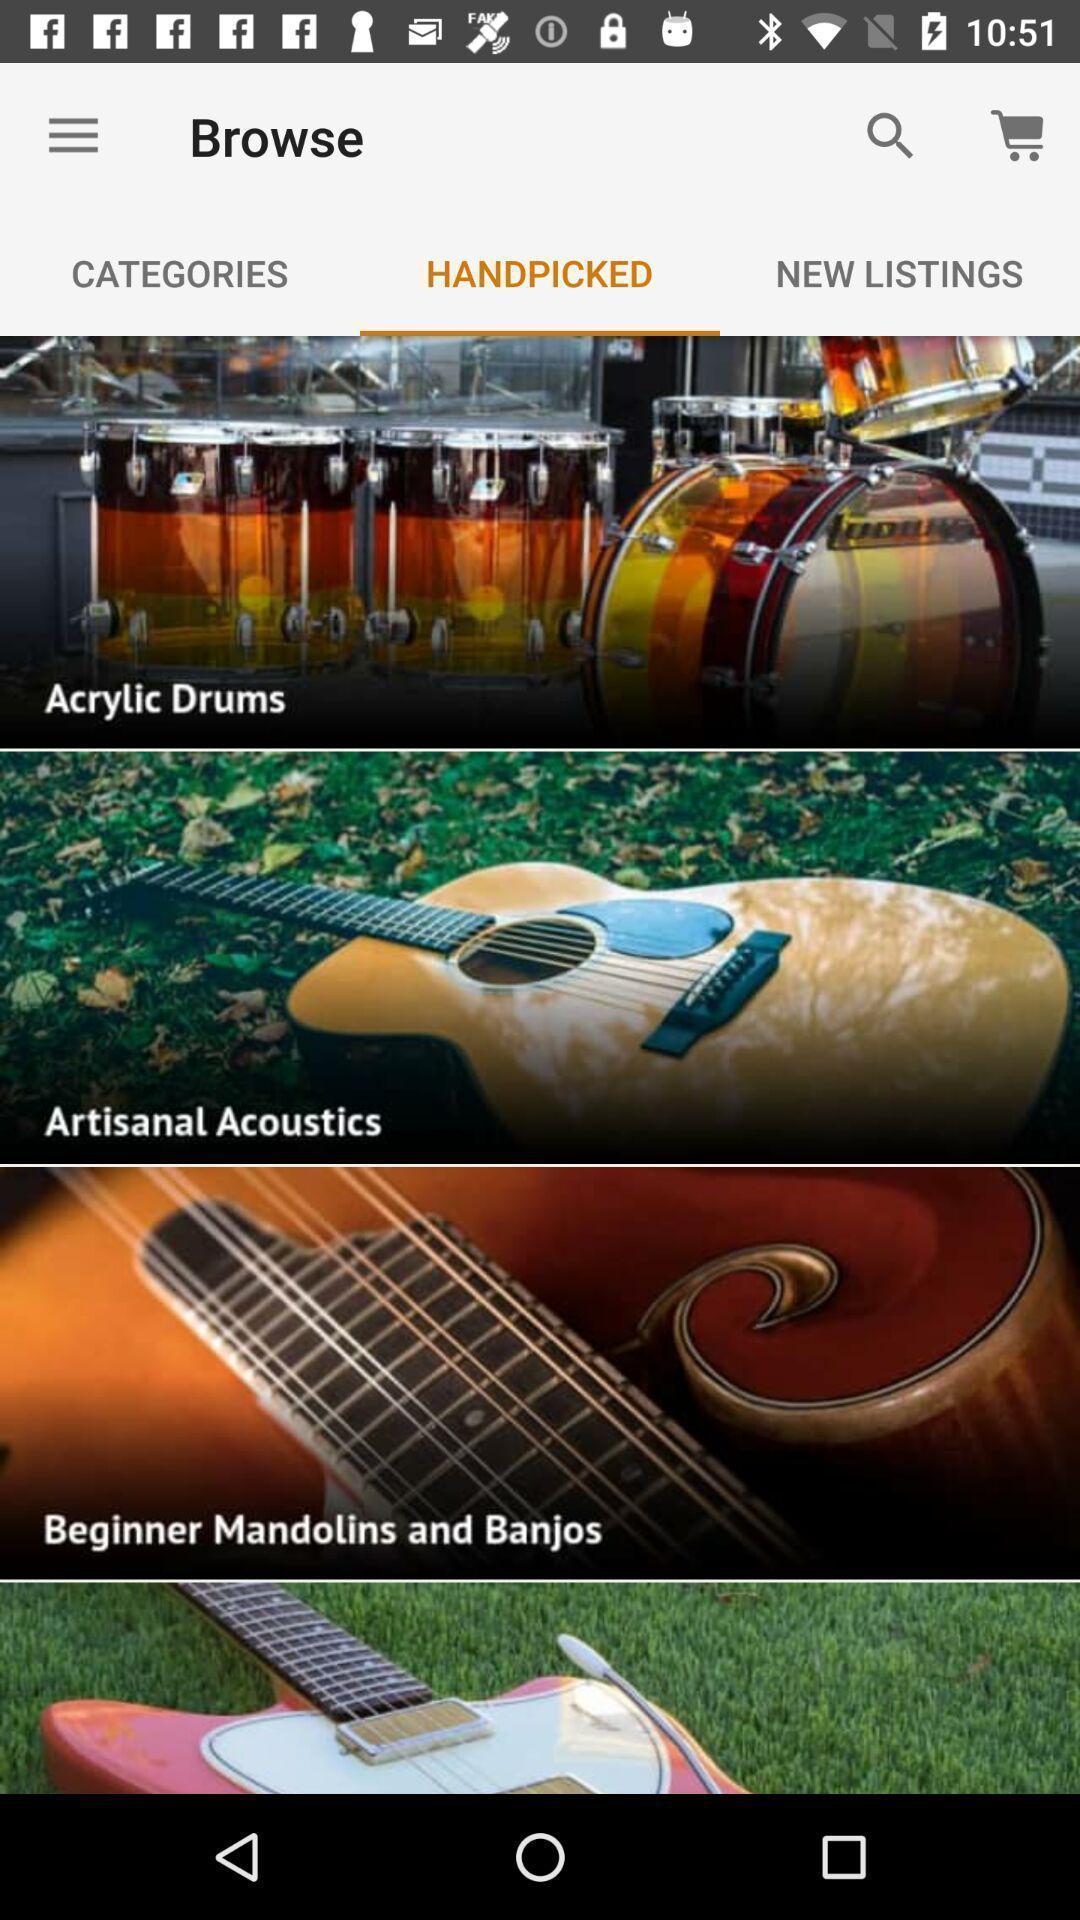Explain the elements present in this screenshot. Screen displaying handpicked music instruments. 